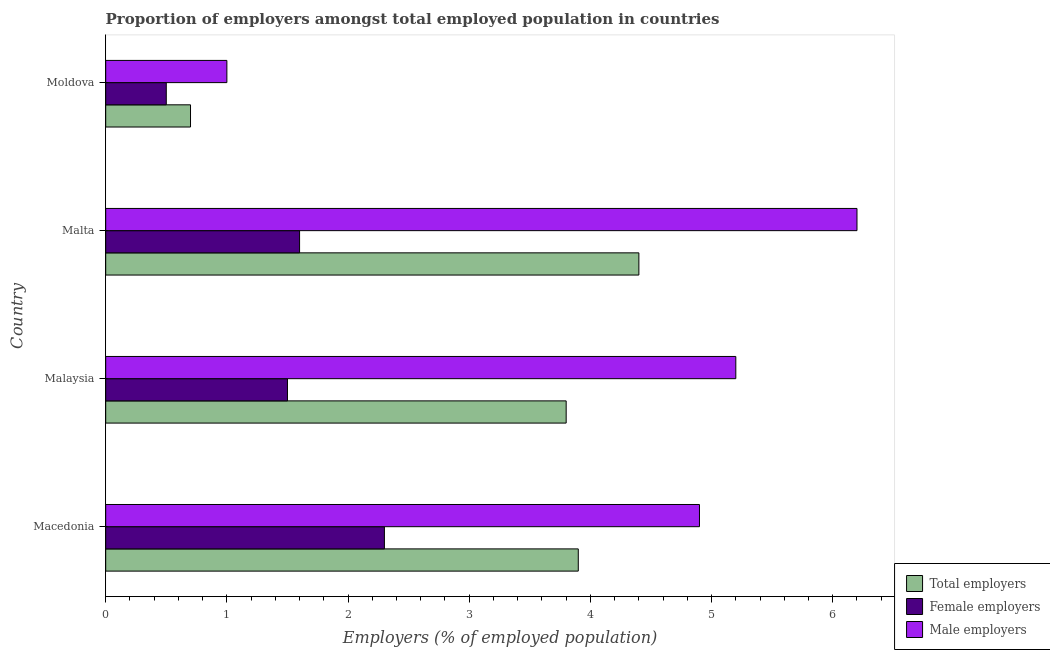How many groups of bars are there?
Your answer should be compact. 4. Are the number of bars on each tick of the Y-axis equal?
Ensure brevity in your answer.  Yes. How many bars are there on the 4th tick from the bottom?
Offer a terse response. 3. What is the label of the 4th group of bars from the top?
Offer a terse response. Macedonia. What is the percentage of female employers in Macedonia?
Give a very brief answer. 2.3. Across all countries, what is the maximum percentage of total employers?
Make the answer very short. 4.4. Across all countries, what is the minimum percentage of male employers?
Provide a succinct answer. 1. In which country was the percentage of male employers maximum?
Your answer should be compact. Malta. In which country was the percentage of male employers minimum?
Make the answer very short. Moldova. What is the total percentage of female employers in the graph?
Your answer should be very brief. 5.9. What is the difference between the percentage of male employers in Macedonia and that in Malta?
Make the answer very short. -1.3. What is the difference between the percentage of female employers in Moldova and the percentage of total employers in Malta?
Your answer should be compact. -3.9. What is the average percentage of female employers per country?
Offer a terse response. 1.48. What is the ratio of the percentage of total employers in Macedonia to that in Moldova?
Make the answer very short. 5.57. Is the percentage of female employers in Macedonia less than that in Moldova?
Provide a succinct answer. No. Is the sum of the percentage of female employers in Macedonia and Malaysia greater than the maximum percentage of total employers across all countries?
Your response must be concise. No. What does the 1st bar from the top in Moldova represents?
Provide a short and direct response. Male employers. What does the 2nd bar from the bottom in Macedonia represents?
Offer a very short reply. Female employers. How many bars are there?
Offer a terse response. 12. Are all the bars in the graph horizontal?
Ensure brevity in your answer.  Yes. How many countries are there in the graph?
Keep it short and to the point. 4. What is the difference between two consecutive major ticks on the X-axis?
Your answer should be compact. 1. Are the values on the major ticks of X-axis written in scientific E-notation?
Ensure brevity in your answer.  No. Where does the legend appear in the graph?
Give a very brief answer. Bottom right. How many legend labels are there?
Your answer should be very brief. 3. How are the legend labels stacked?
Provide a short and direct response. Vertical. What is the title of the graph?
Offer a very short reply. Proportion of employers amongst total employed population in countries. What is the label or title of the X-axis?
Your answer should be compact. Employers (% of employed population). What is the Employers (% of employed population) in Total employers in Macedonia?
Ensure brevity in your answer.  3.9. What is the Employers (% of employed population) of Female employers in Macedonia?
Provide a short and direct response. 2.3. What is the Employers (% of employed population) of Male employers in Macedonia?
Your answer should be compact. 4.9. What is the Employers (% of employed population) of Total employers in Malaysia?
Ensure brevity in your answer.  3.8. What is the Employers (% of employed population) of Female employers in Malaysia?
Provide a short and direct response. 1.5. What is the Employers (% of employed population) of Male employers in Malaysia?
Give a very brief answer. 5.2. What is the Employers (% of employed population) in Total employers in Malta?
Provide a short and direct response. 4.4. What is the Employers (% of employed population) in Female employers in Malta?
Your response must be concise. 1.6. What is the Employers (% of employed population) of Male employers in Malta?
Provide a short and direct response. 6.2. What is the Employers (% of employed population) in Total employers in Moldova?
Make the answer very short. 0.7. What is the Employers (% of employed population) in Male employers in Moldova?
Offer a very short reply. 1. Across all countries, what is the maximum Employers (% of employed population) of Total employers?
Your response must be concise. 4.4. Across all countries, what is the maximum Employers (% of employed population) of Female employers?
Give a very brief answer. 2.3. Across all countries, what is the maximum Employers (% of employed population) in Male employers?
Your response must be concise. 6.2. Across all countries, what is the minimum Employers (% of employed population) in Total employers?
Your response must be concise. 0.7. Across all countries, what is the minimum Employers (% of employed population) of Female employers?
Give a very brief answer. 0.5. Across all countries, what is the minimum Employers (% of employed population) of Male employers?
Your answer should be very brief. 1. What is the total Employers (% of employed population) in Total employers in the graph?
Provide a short and direct response. 12.8. What is the total Employers (% of employed population) of Female employers in the graph?
Offer a terse response. 5.9. What is the difference between the Employers (% of employed population) of Male employers in Macedonia and that in Malaysia?
Offer a very short reply. -0.3. What is the difference between the Employers (% of employed population) in Total employers in Macedonia and that in Malta?
Provide a succinct answer. -0.5. What is the difference between the Employers (% of employed population) in Male employers in Macedonia and that in Malta?
Make the answer very short. -1.3. What is the difference between the Employers (% of employed population) of Total employers in Macedonia and that in Moldova?
Keep it short and to the point. 3.2. What is the difference between the Employers (% of employed population) of Male employers in Macedonia and that in Moldova?
Make the answer very short. 3.9. What is the difference between the Employers (% of employed population) of Total employers in Malaysia and that in Malta?
Provide a short and direct response. -0.6. What is the difference between the Employers (% of employed population) of Male employers in Malaysia and that in Malta?
Your answer should be very brief. -1. What is the difference between the Employers (% of employed population) in Total employers in Malaysia and that in Moldova?
Your answer should be very brief. 3.1. What is the difference between the Employers (% of employed population) in Female employers in Malaysia and that in Moldova?
Keep it short and to the point. 1. What is the difference between the Employers (% of employed population) in Male employers in Malaysia and that in Moldova?
Offer a terse response. 4.2. What is the difference between the Employers (% of employed population) in Male employers in Malta and that in Moldova?
Provide a succinct answer. 5.2. What is the difference between the Employers (% of employed population) of Total employers in Macedonia and the Employers (% of employed population) of Male employers in Malaysia?
Make the answer very short. -1.3. What is the difference between the Employers (% of employed population) in Female employers in Macedonia and the Employers (% of employed population) in Male employers in Malaysia?
Make the answer very short. -2.9. What is the difference between the Employers (% of employed population) in Total employers in Macedonia and the Employers (% of employed population) in Male employers in Malta?
Ensure brevity in your answer.  -2.3. What is the difference between the Employers (% of employed population) in Total employers in Macedonia and the Employers (% of employed population) in Female employers in Moldova?
Your response must be concise. 3.4. What is the difference between the Employers (% of employed population) of Female employers in Macedonia and the Employers (% of employed population) of Male employers in Moldova?
Your answer should be compact. 1.3. What is the difference between the Employers (% of employed population) in Female employers in Malaysia and the Employers (% of employed population) in Male employers in Malta?
Provide a short and direct response. -4.7. What is the difference between the Employers (% of employed population) of Total employers in Malaysia and the Employers (% of employed population) of Female employers in Moldova?
Your answer should be very brief. 3.3. What is the difference between the Employers (% of employed population) in Total employers in Malta and the Employers (% of employed population) in Male employers in Moldova?
Provide a short and direct response. 3.4. What is the difference between the Employers (% of employed population) of Female employers in Malta and the Employers (% of employed population) of Male employers in Moldova?
Your answer should be compact. 0.6. What is the average Employers (% of employed population) in Female employers per country?
Provide a succinct answer. 1.48. What is the average Employers (% of employed population) of Male employers per country?
Give a very brief answer. 4.33. What is the difference between the Employers (% of employed population) of Total employers and Employers (% of employed population) of Female employers in Malaysia?
Your answer should be compact. 2.3. What is the difference between the Employers (% of employed population) of Total employers and Employers (% of employed population) of Male employers in Malaysia?
Keep it short and to the point. -1.4. What is the difference between the Employers (% of employed population) of Total employers and Employers (% of employed population) of Female employers in Moldova?
Provide a succinct answer. 0.2. What is the ratio of the Employers (% of employed population) of Total employers in Macedonia to that in Malaysia?
Give a very brief answer. 1.03. What is the ratio of the Employers (% of employed population) of Female employers in Macedonia to that in Malaysia?
Your response must be concise. 1.53. What is the ratio of the Employers (% of employed population) of Male employers in Macedonia to that in Malaysia?
Offer a terse response. 0.94. What is the ratio of the Employers (% of employed population) of Total employers in Macedonia to that in Malta?
Ensure brevity in your answer.  0.89. What is the ratio of the Employers (% of employed population) in Female employers in Macedonia to that in Malta?
Keep it short and to the point. 1.44. What is the ratio of the Employers (% of employed population) of Male employers in Macedonia to that in Malta?
Your response must be concise. 0.79. What is the ratio of the Employers (% of employed population) in Total employers in Macedonia to that in Moldova?
Your answer should be very brief. 5.57. What is the ratio of the Employers (% of employed population) of Male employers in Macedonia to that in Moldova?
Your answer should be compact. 4.9. What is the ratio of the Employers (% of employed population) in Total employers in Malaysia to that in Malta?
Your response must be concise. 0.86. What is the ratio of the Employers (% of employed population) in Male employers in Malaysia to that in Malta?
Your answer should be very brief. 0.84. What is the ratio of the Employers (% of employed population) of Total employers in Malaysia to that in Moldova?
Offer a terse response. 5.43. What is the ratio of the Employers (% of employed population) of Female employers in Malaysia to that in Moldova?
Ensure brevity in your answer.  3. What is the ratio of the Employers (% of employed population) of Male employers in Malaysia to that in Moldova?
Provide a succinct answer. 5.2. What is the ratio of the Employers (% of employed population) in Total employers in Malta to that in Moldova?
Give a very brief answer. 6.29. What is the ratio of the Employers (% of employed population) of Female employers in Malta to that in Moldova?
Give a very brief answer. 3.2. What is the difference between the highest and the lowest Employers (% of employed population) in Female employers?
Make the answer very short. 1.8. What is the difference between the highest and the lowest Employers (% of employed population) of Male employers?
Offer a very short reply. 5.2. 